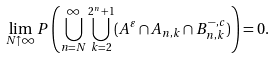<formula> <loc_0><loc_0><loc_500><loc_500>\lim _ { N \uparrow \infty } P \left ( \bigcup _ { n = N } ^ { \infty } \bigcup _ { k = 2 } ^ { 2 ^ { n } + 1 } ( A ^ { \varepsilon } \cap A _ { n , k } \cap B _ { n , k } ^ { - , c } ) \right ) = 0 .</formula> 